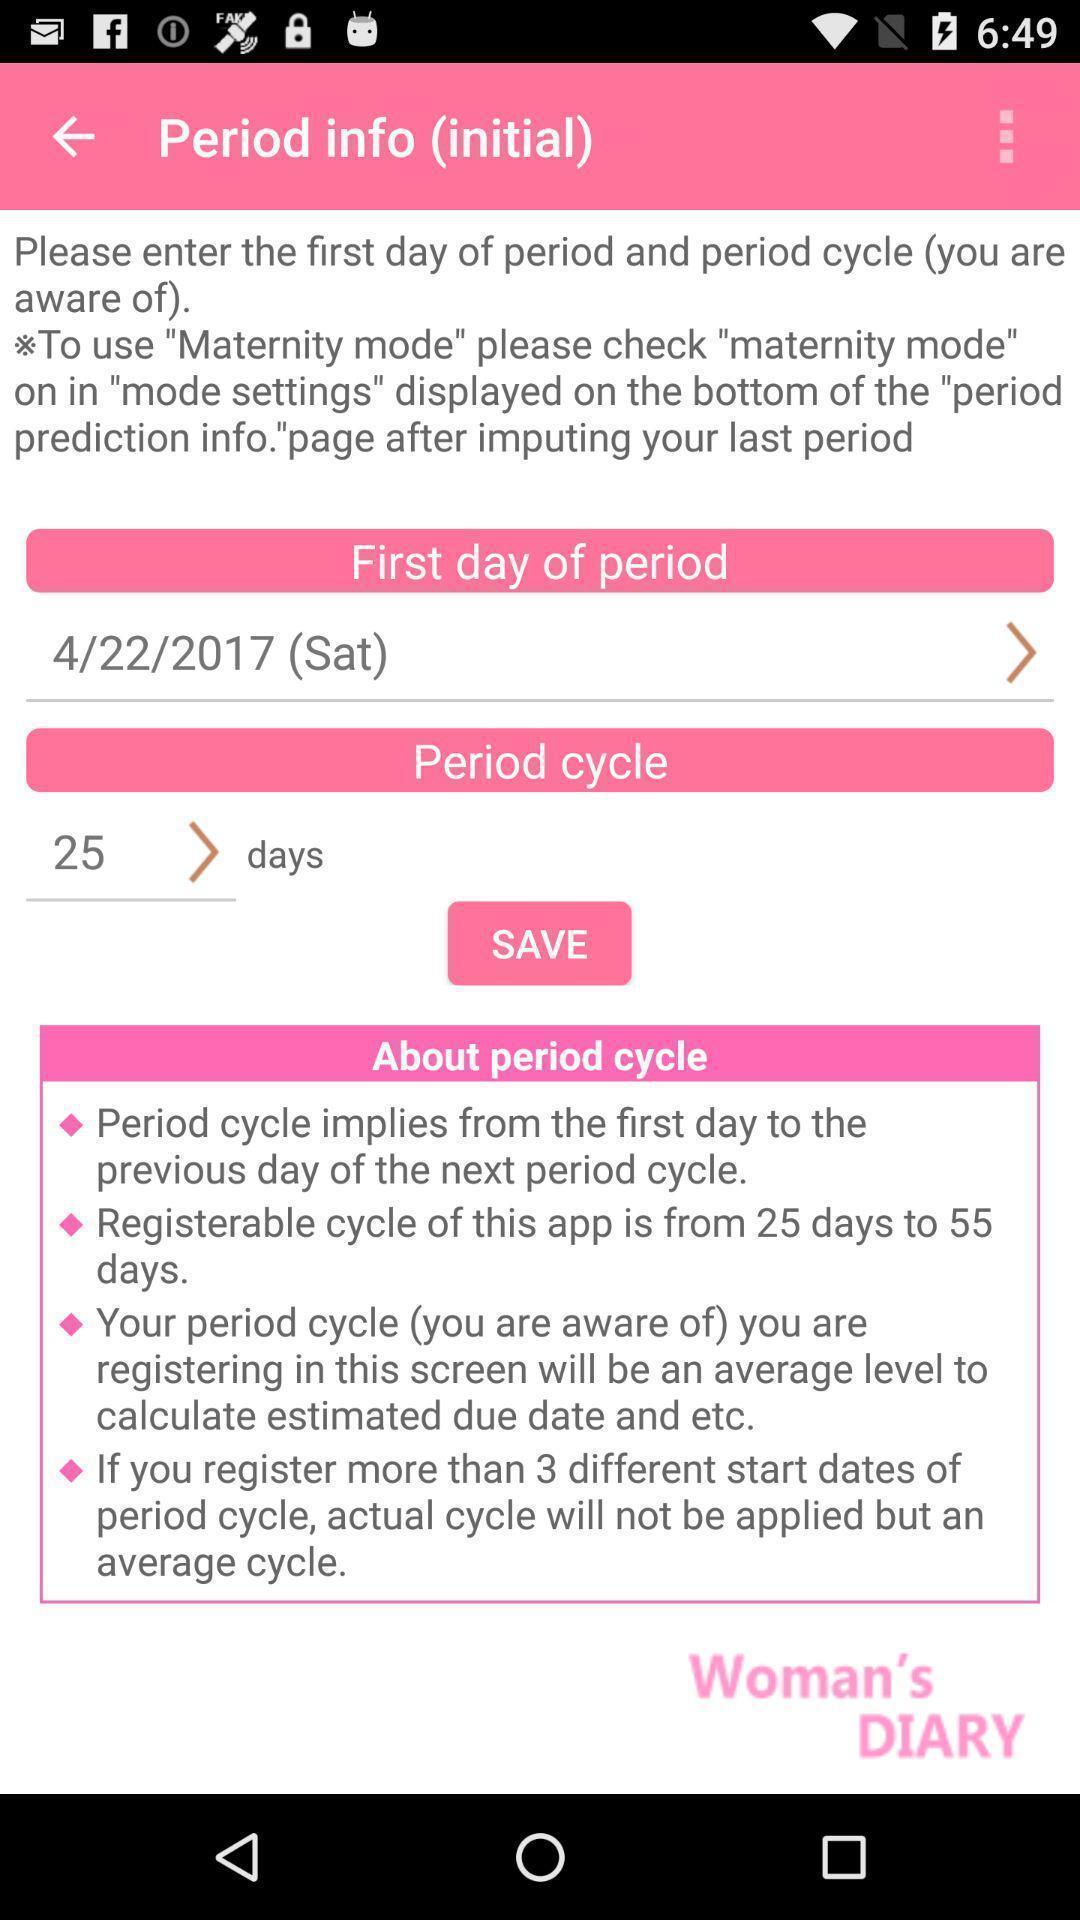Explain what's happening in this screen capture. Page displaying to set the information to customize the application. 